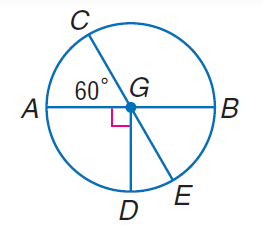Find m \angle D G E. To find the measure of angle DGE in the given circle, one must use the properties of a circle and the fact that DG is a radius, thereby making angle DGE a central angle which is equal to the arc it subtends. Since no arc measure is indicated for arc DE, it cannot be determined directly from the image. The correct approach involves understanding the relationship between central angles and their corresponding arc lengths. However, without further information or additional context, the value of m \angle D GE cannot be accurately determined from the provided image alone. 